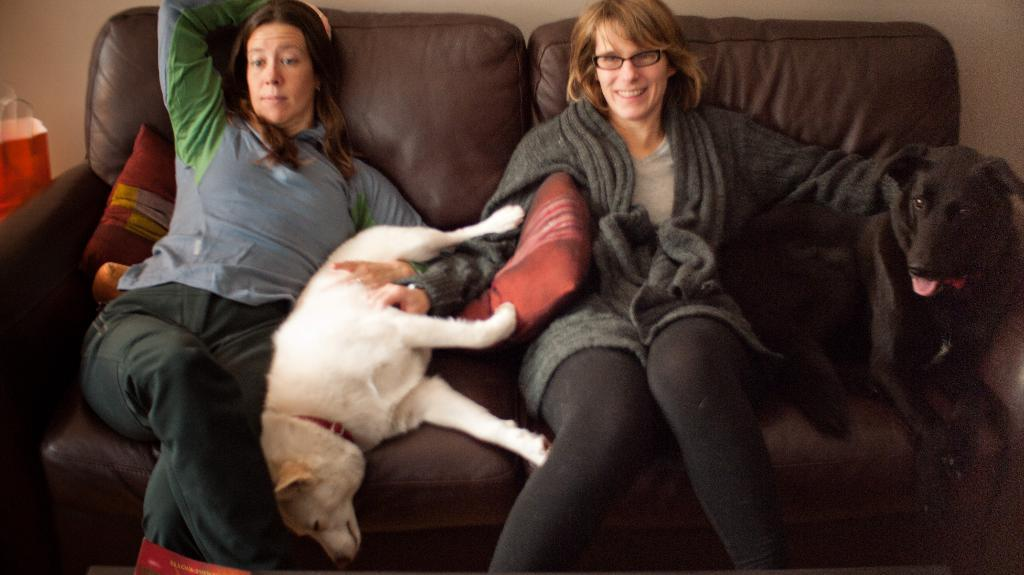How many people are in the image? There are two persons in the image. What other living beings are present in the image? There are dogs in the image. Where are the persons and dogs located? They are on a couch in the image. What type of furniture accessory can be seen in the image? There are pillows in the image. What is the background of the image composed of? There is a wall in the image. What is covering the couch? There is a cover in the image. What type of twig is being used as a potato masher in the image? There is no twig or potato masher present in the image. How does the temper of the persons and dogs affect the atmosphere in the image? The temper of the persons and dogs cannot be determined from the image, as their emotions are not visible. 